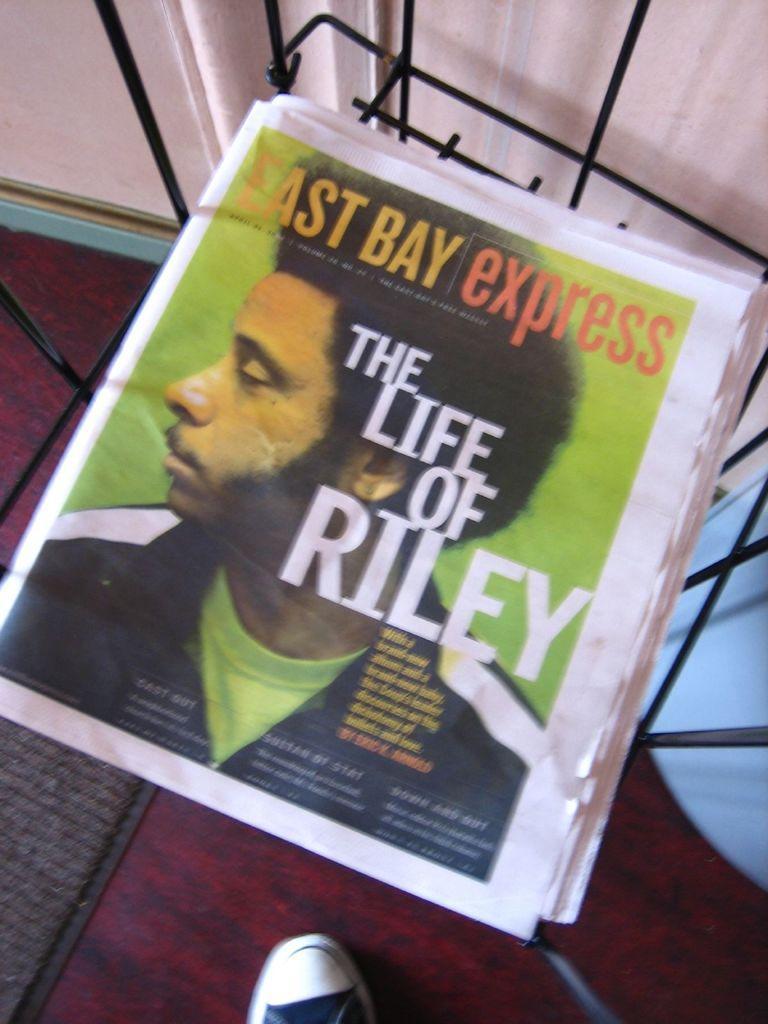How would you summarize this image in a sentence or two? In this image we can see papers on the stand. 